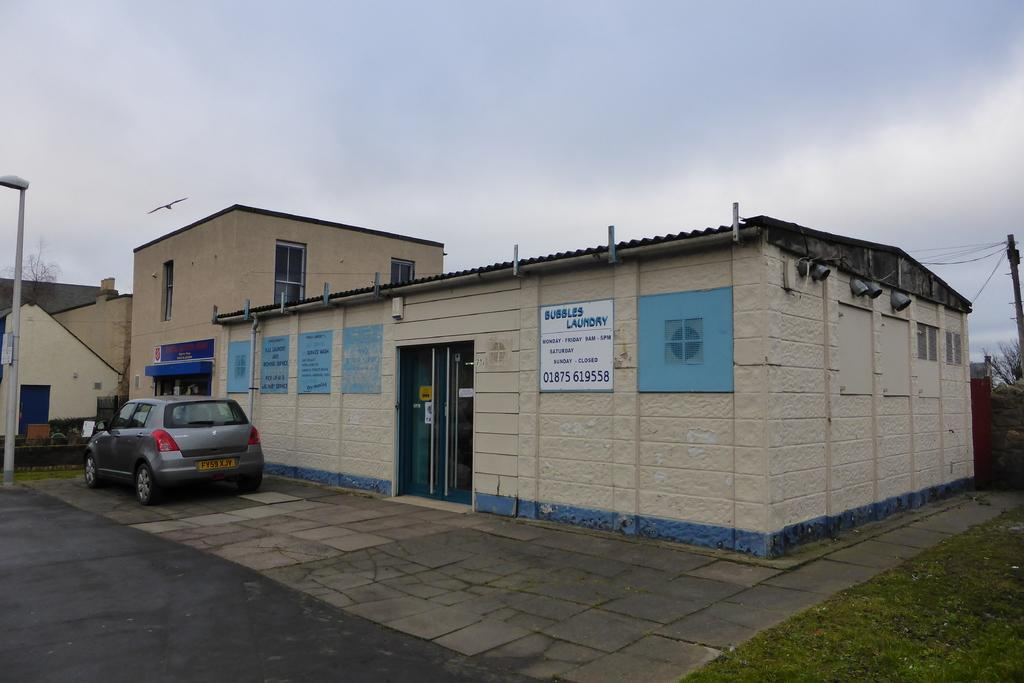What type of structures can be seen in the image? There are buildings in the image. What other objects can be seen in the image besides buildings? There are poles, wires, windows, doors, boards, trees, and a vehicle visible in the image. Can you describe the background of the image? The sky is visible in the background of the image. What type of harmony is being played by the elbow in the image? There is no mention of harmony or elbows in the image; it features buildings, poles, wires, windows, doors, boards, trees, and a vehicle. 